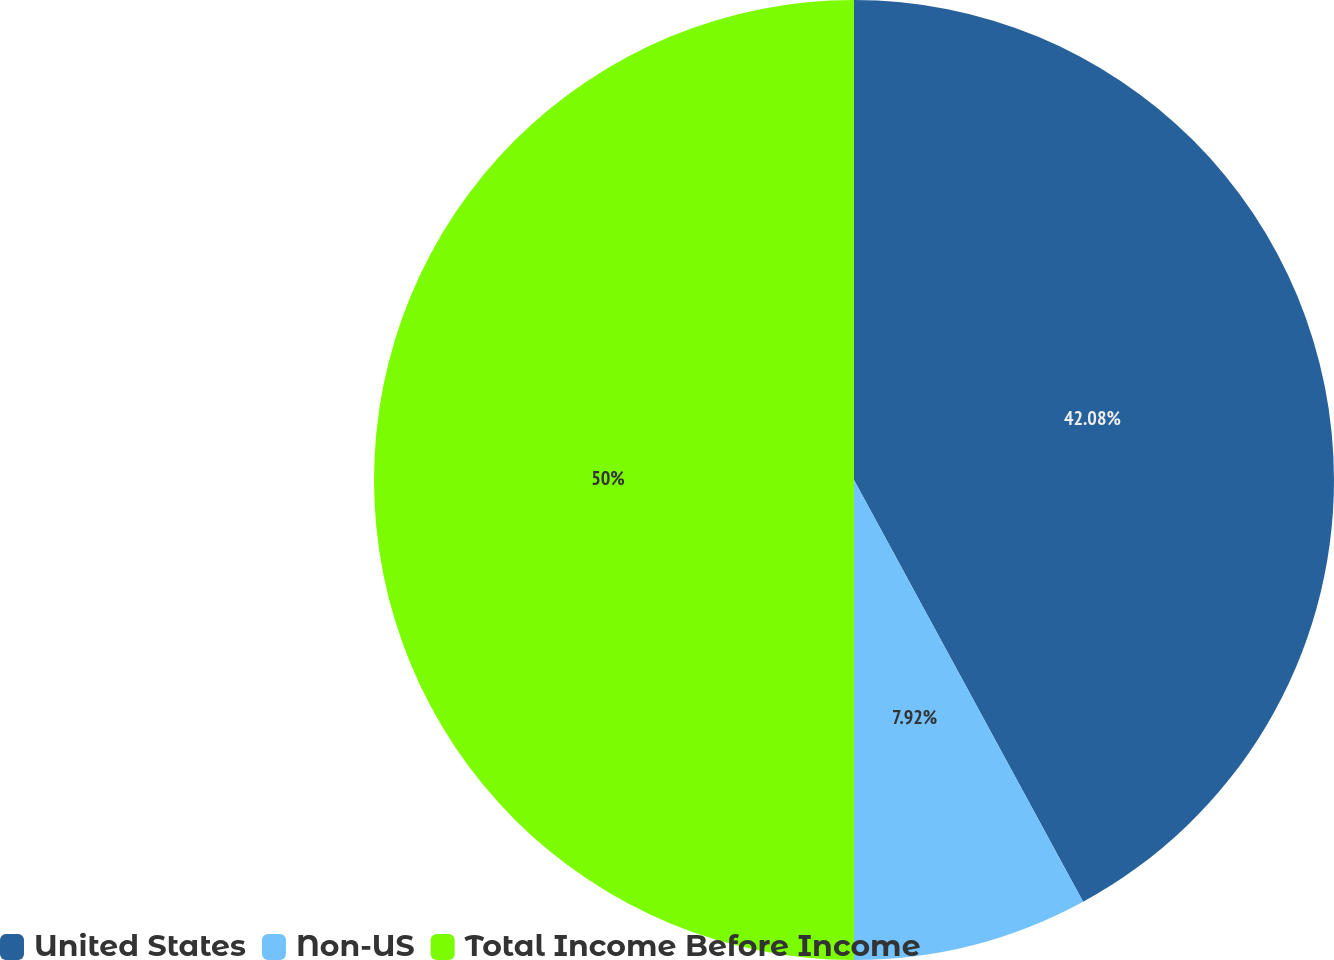Convert chart. <chart><loc_0><loc_0><loc_500><loc_500><pie_chart><fcel>United States<fcel>Non-US<fcel>Total Income Before Income<nl><fcel>42.08%<fcel>7.92%<fcel>50.0%<nl></chart> 